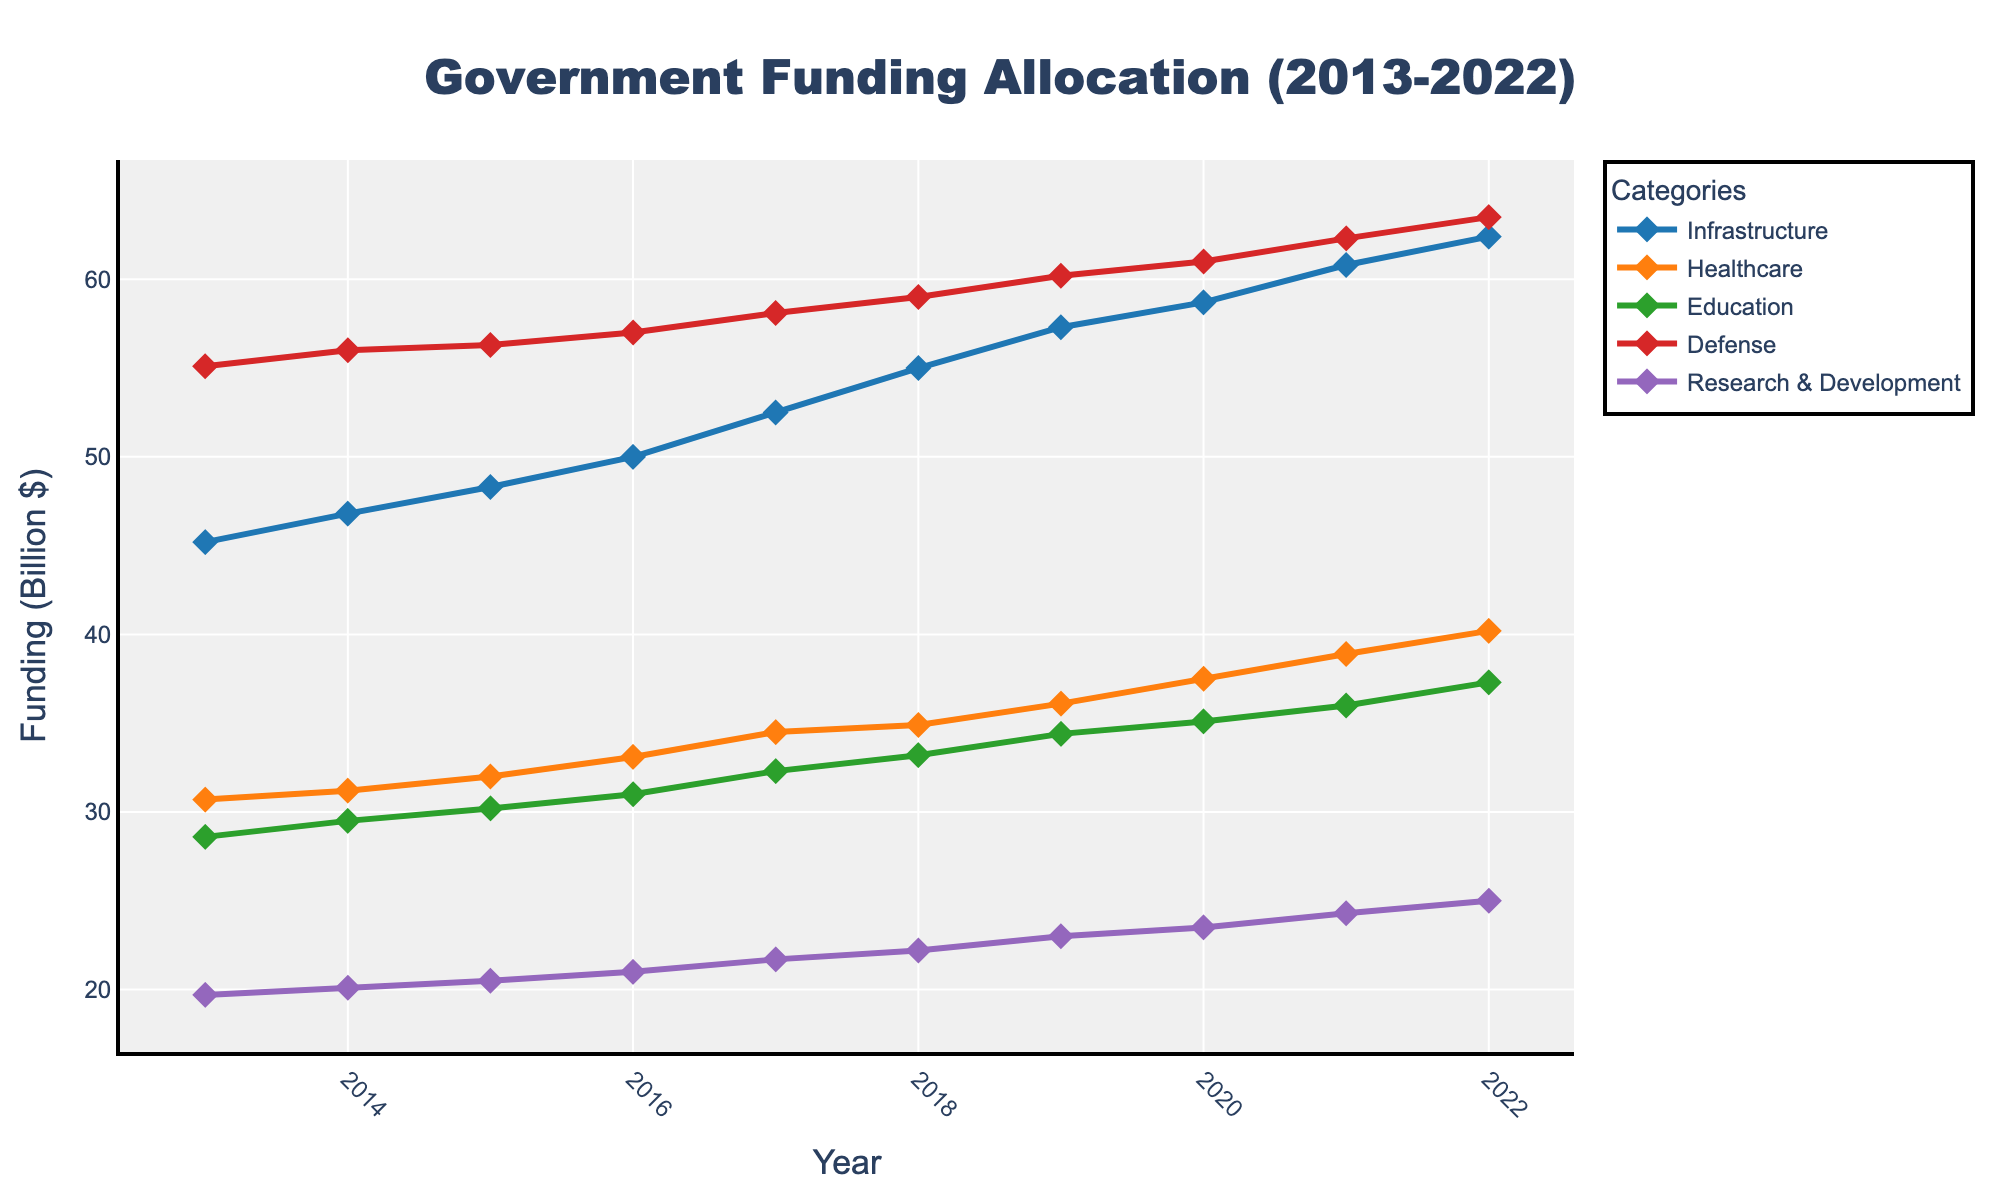What is the title of the plot? The title is displayed at the top of the plot and reads 'Government Funding Allocation (2013-2022)'.
Answer: Government Funding Allocation (2013-2022) Which project type had the highest funding in 2022? To find this, look at the end of each line for 2022. The Defense category has the highest value.
Answer: Defense What was the funding allocation for Healthcare in 2015? Locate the point on the Healthcare line that corresponds to the year 2015, which shows a value of 32.0 billion $.
Answer: 32.0 billion $ How many project types are represented in the plot? Count the number of distinct lines or legend entries. There are five project types.
Answer: 5 Which project type experienced the largest increase in funding from 2013 to 2022? Find the difference between the funding allocations for 2022 and 2013 for each category. The Infrastructure category has the largest increase (62.4 - 45.2 = 17.2 billion $).
Answer: Infrastructure What is the approximate average funding allocation for Education from 2013 to 2022? Calculate the sum of Education funding values from 2013 to 2022 and divide by the number of years (28.6 + 29.5 + 30.2 + 31.0 + 32.3 + 33.2 + 34.4 + 35.1 + 36.0 + 37.3) / 10 = 32.76 billion $.
Answer: 32.76 billion $ Which project type had the least variability in funding allocation over the decade? Assess the spread or range of funding values for each category over the years. The Research & Development category has the smallest range (25.0 - 19.7 = 5.3 billion $).
Answer: Research & Development What year did Defense funding first exceed 60 billion $? Follow the Defense line until it surpasses 60 billion $. It first exceeds 60 billion $ in 2019.
Answer: 2019 How much did Healthcare funding increase between 2017 and 2020? Subtract the funding value of Healthcare in 2017 from that in 2020 (37.5 - 34.5 = 3.0 billion $).
Answer: 3.0 billion $ 